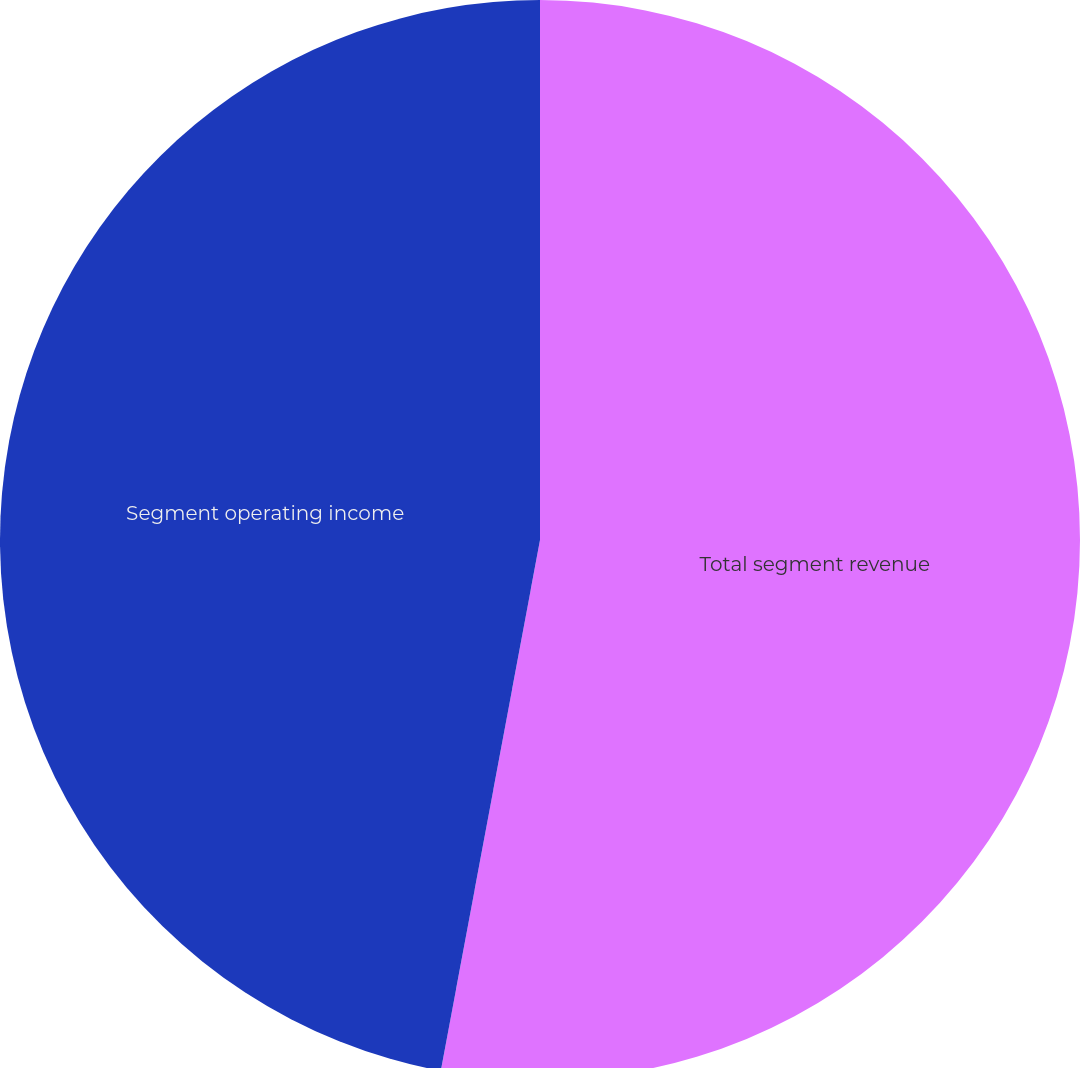Convert chart. <chart><loc_0><loc_0><loc_500><loc_500><pie_chart><fcel>Total segment revenue<fcel>Segment operating income<nl><fcel>52.94%<fcel>47.06%<nl></chart> 